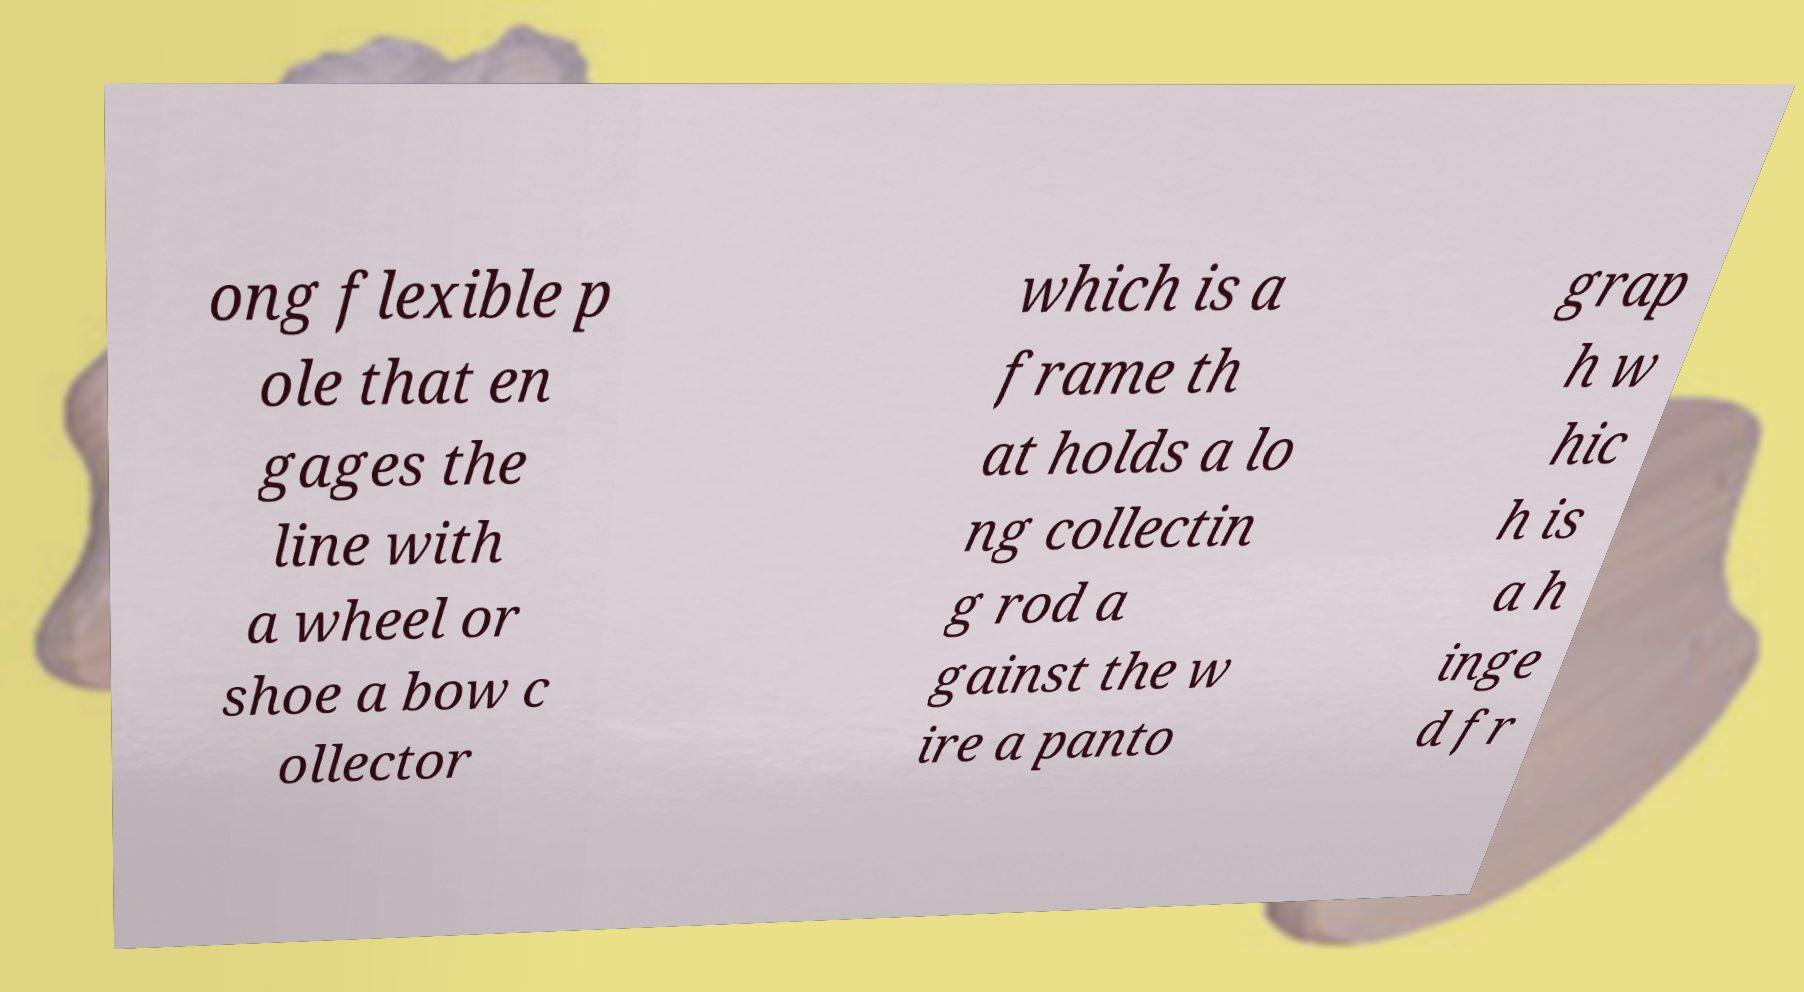There's text embedded in this image that I need extracted. Can you transcribe it verbatim? ong flexible p ole that en gages the line with a wheel or shoe a bow c ollector which is a frame th at holds a lo ng collectin g rod a gainst the w ire a panto grap h w hic h is a h inge d fr 